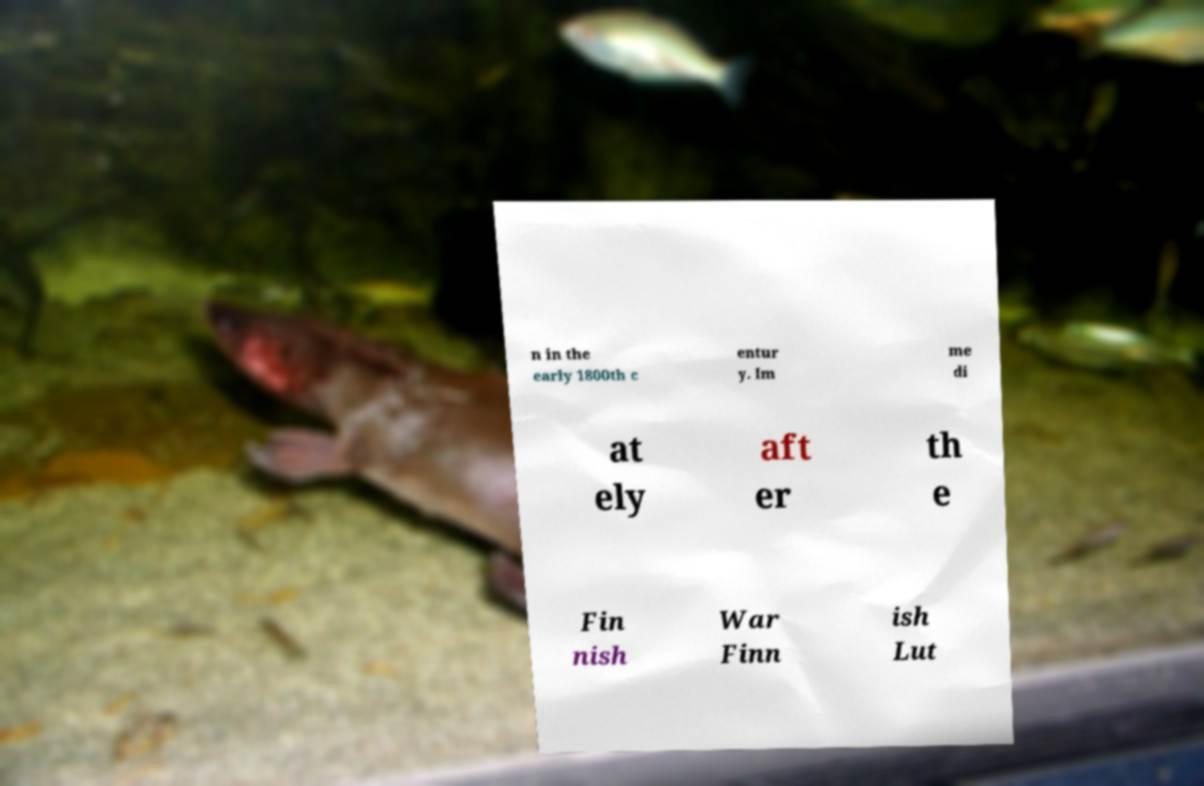For documentation purposes, I need the text within this image transcribed. Could you provide that? n in the early 1800th c entur y. Im me di at ely aft er th e Fin nish War Finn ish Lut 